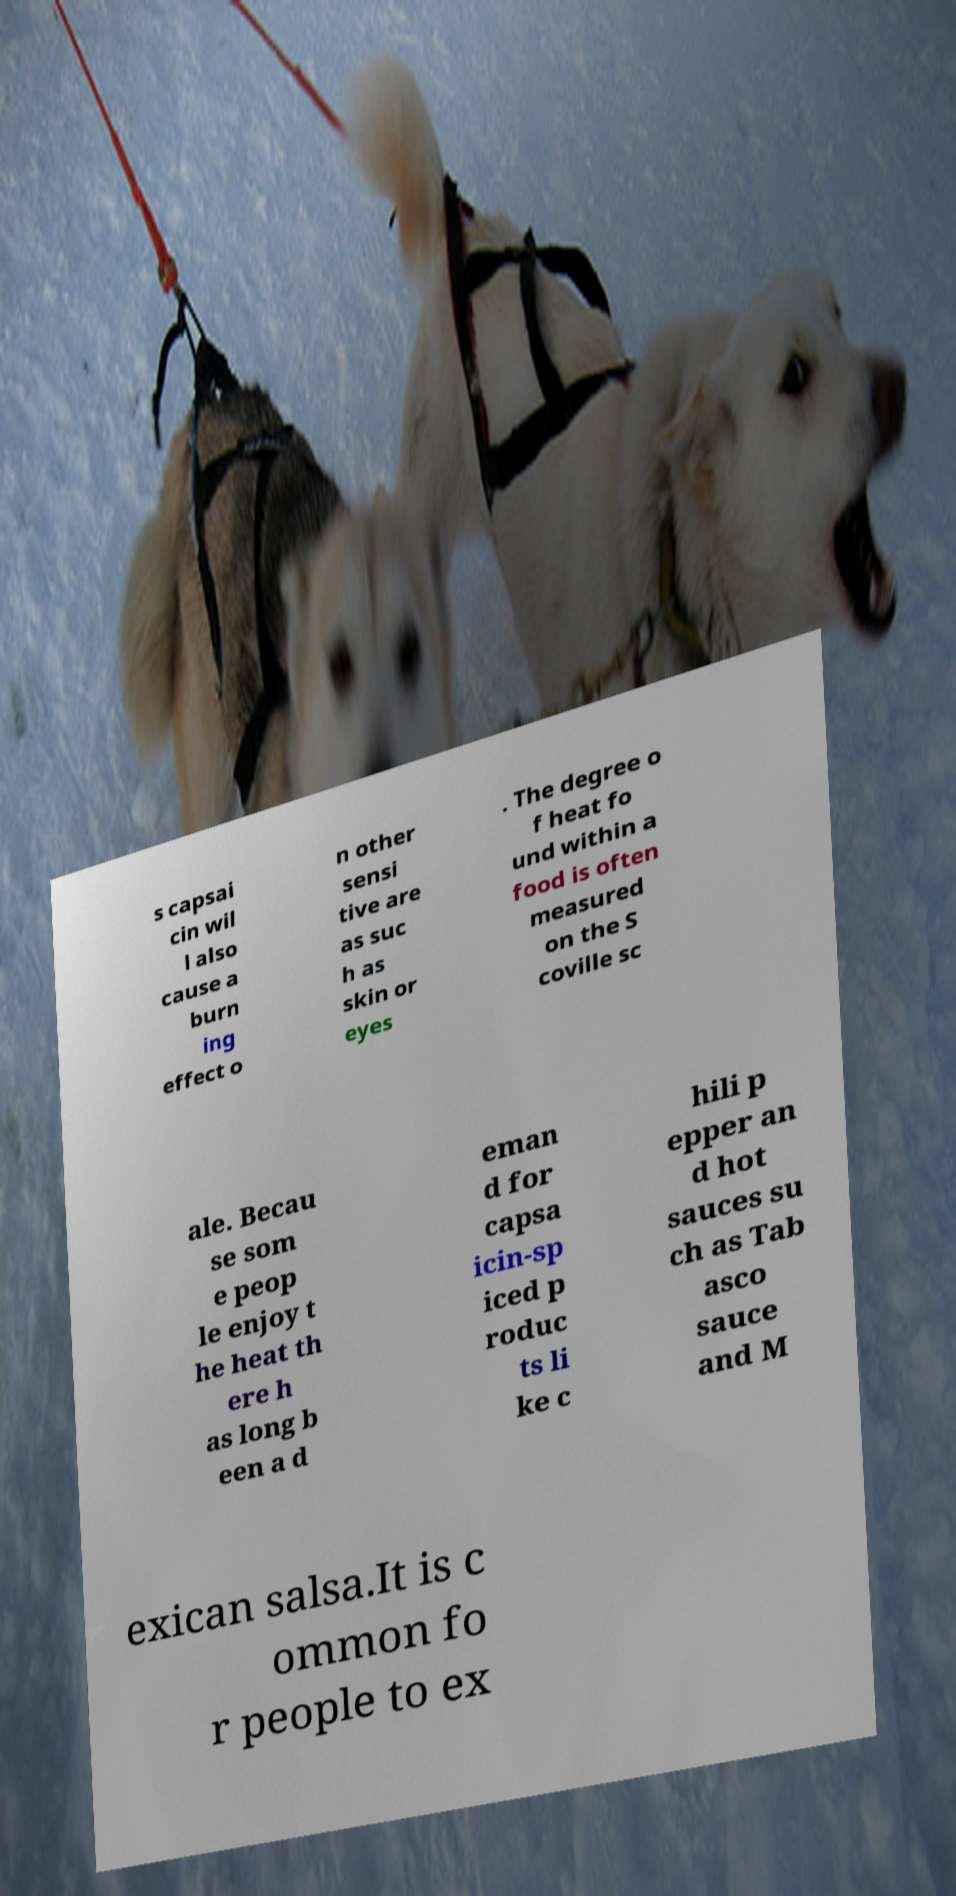I need the written content from this picture converted into text. Can you do that? s capsai cin wil l also cause a burn ing effect o n other sensi tive are as suc h as skin or eyes . The degree o f heat fo und within a food is often measured on the S coville sc ale. Becau se som e peop le enjoy t he heat th ere h as long b een a d eman d for capsa icin-sp iced p roduc ts li ke c hili p epper an d hot sauces su ch as Tab asco sauce and M exican salsa.It is c ommon fo r people to ex 